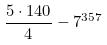Convert formula to latex. <formula><loc_0><loc_0><loc_500><loc_500>\frac { 5 \cdot 1 4 0 } { 4 } - 7 ^ { 3 5 7 }</formula> 